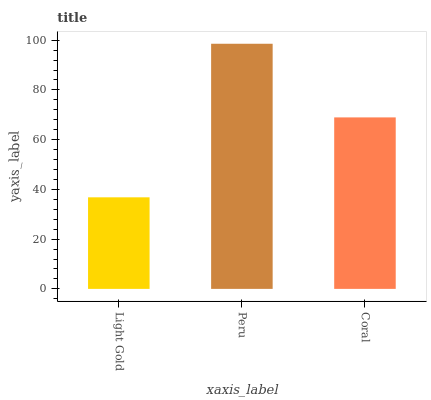Is Light Gold the minimum?
Answer yes or no. Yes. Is Peru the maximum?
Answer yes or no. Yes. Is Coral the minimum?
Answer yes or no. No. Is Coral the maximum?
Answer yes or no. No. Is Peru greater than Coral?
Answer yes or no. Yes. Is Coral less than Peru?
Answer yes or no. Yes. Is Coral greater than Peru?
Answer yes or no. No. Is Peru less than Coral?
Answer yes or no. No. Is Coral the high median?
Answer yes or no. Yes. Is Coral the low median?
Answer yes or no. Yes. Is Light Gold the high median?
Answer yes or no. No. Is Light Gold the low median?
Answer yes or no. No. 